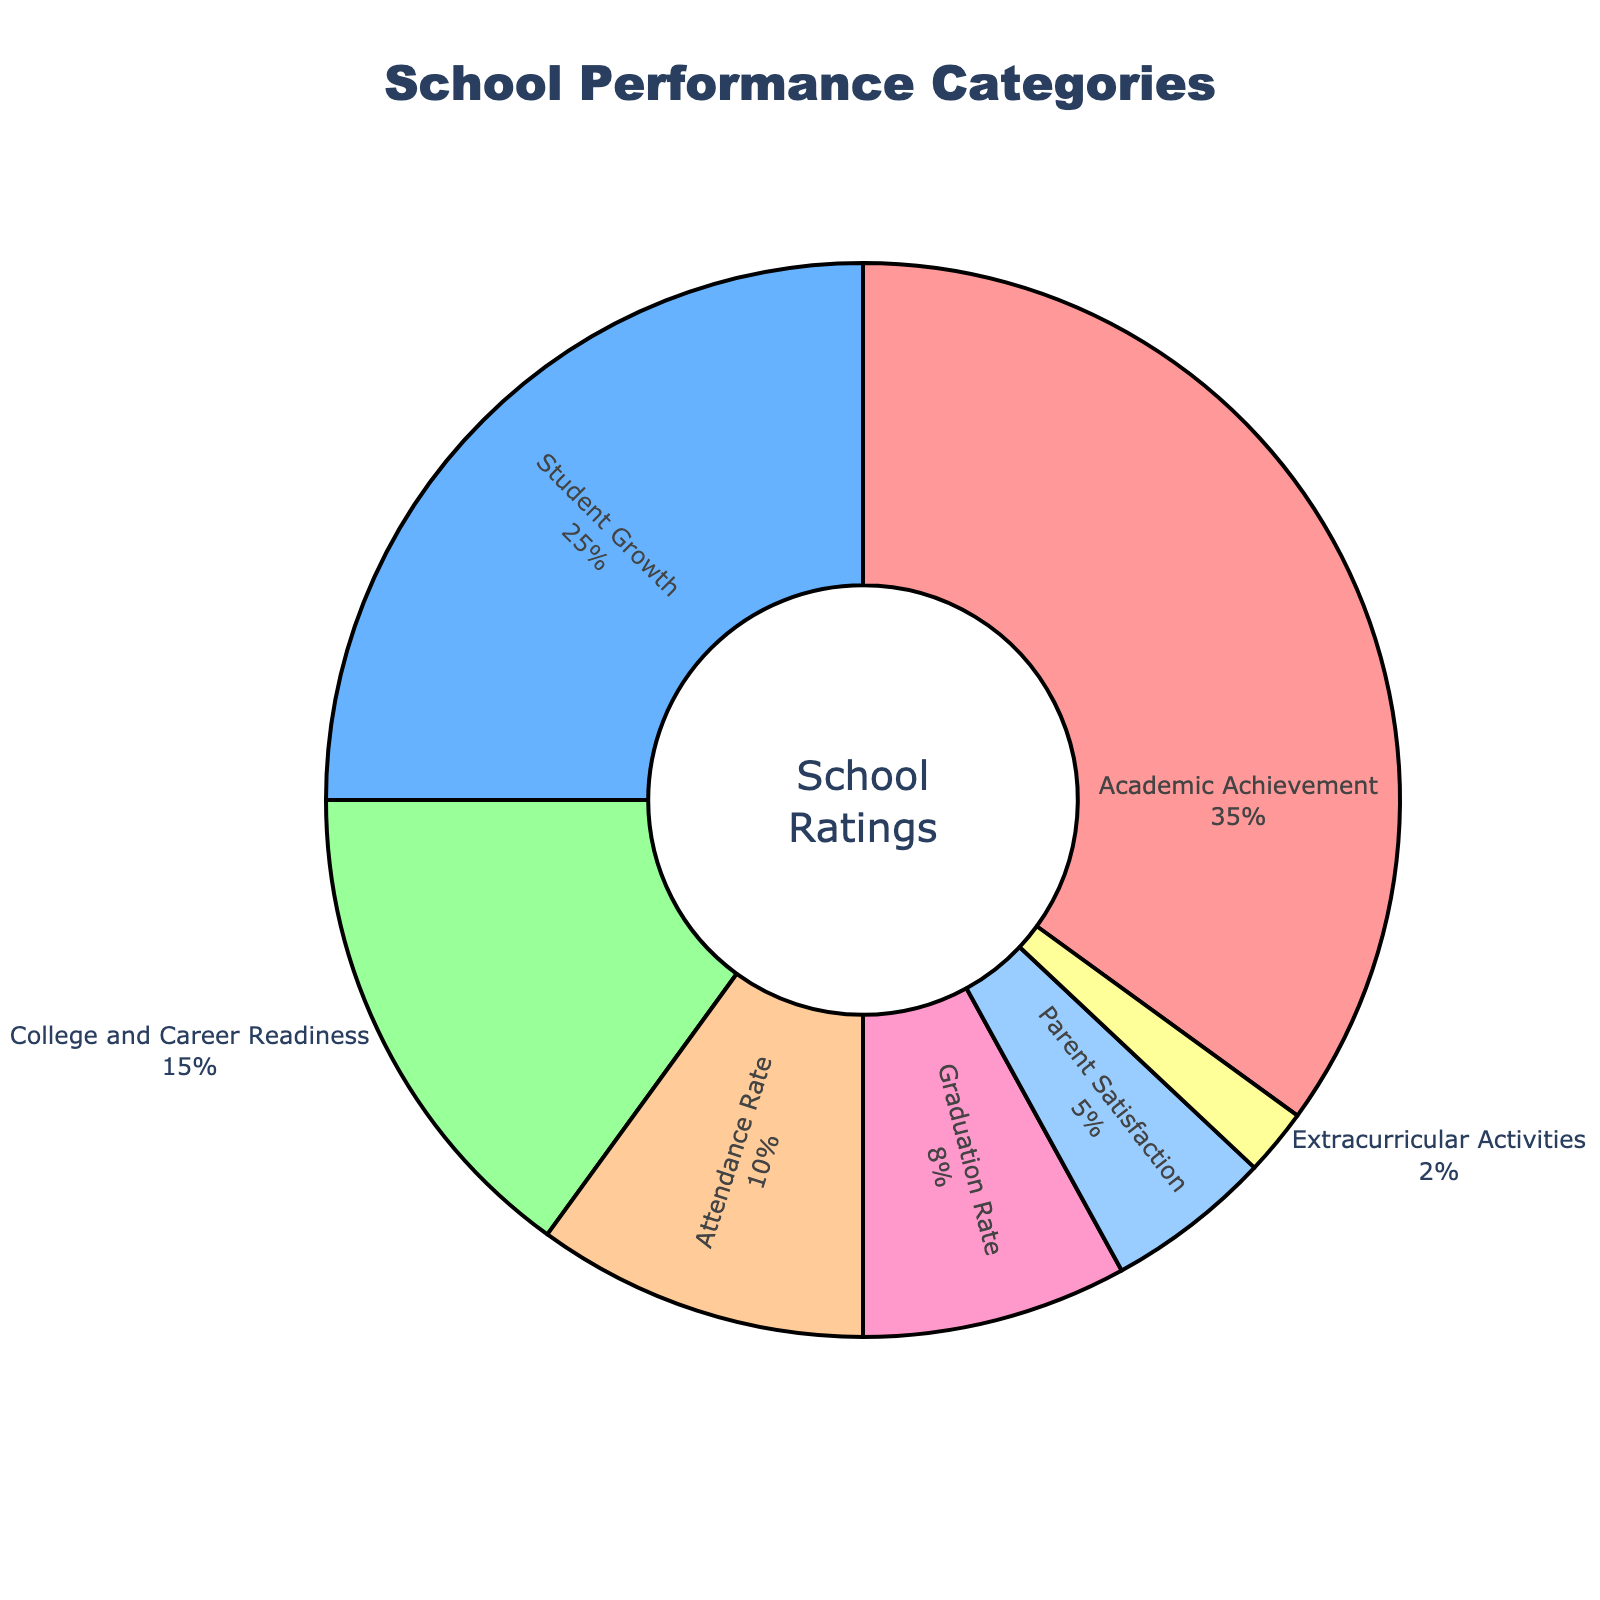Which category has the highest percentage? The category with the highest percentage is "Academic Achievement" which accounts for 35% according to the pie chart.
Answer: Academic Achievement What is the total percentage of categories related to student performance (Academic Achievement, Student Growth, Graduation Rate)? First, identify the percentages of each category: Academic Achievement (35%), Student Growth (25%), and Graduation Rate (8%). Add them together: 35% + 25% + 8% = 68%.
Answer: 68% Are there more categories above or below 10% in the chart? Count the categories above 10%: Academic Achievement (1), Student Growth (1), College and Career Readiness (1). Count the categories below 10%: Attendance Rate (1), Graduation Rate (1), Parent Satisfaction (1), Extracurricular Activities (1). There are three categories above 10% and four categories below 10%.
Answer: Below 10% Which categories combined make up less than 10% of the chart? The categories that make up less than 10% are Parent Satisfaction (5%) and Extracurricular Activities (2%). Adding these, 5% + 2% = 7%, which is less than 10%.
Answer: Parent Satisfaction and Extracurricular Activities By how much does the percentage of Academic Achievement exceed that of College and Career Readiness? Academic Achievement has a percentage of 35%, while College and Career Readiness has 15%. The difference is 35% - 15% = 20%.
Answer: 20% What are the visual differences between the Attendance Rate and Parent Satisfaction categories in the chart? The Attendance Rate category occupies a larger segment of the pie chart than the Parent Satisfaction category and has different colors. The Attendance Rate is associated with a bigger area than the Parent Satisfaction.
Answer: Attendance Rate has a larger segment and a different color How does the percentage of Student Growth compare to that of Attendance Rate? The percentage of Student Growth (25%) is more than double that of Attendance Rate (10%).
Answer: More than double What is the combined percentage of Attendance Rate and Graduation Rate? The percentages for Attendance Rate and Graduation Rate are 10% and 8%, respectively. Adding these together: 10% + 8% = 18%.
Answer: 18% If the categories of Attendance Rate and Parent Satisfaction are each increased by 1%, what would their new totals be? Current percentages are Attendance Rate (10%) and Parent Satisfaction (5%). After increasing each by 1%, Attendance Rate would be 10% + 1% = 11% and Parent Satisfaction would be 5% + 1% = 6%.
Answer: 11% for Attendance Rate, 6% for Parent Satisfaction 